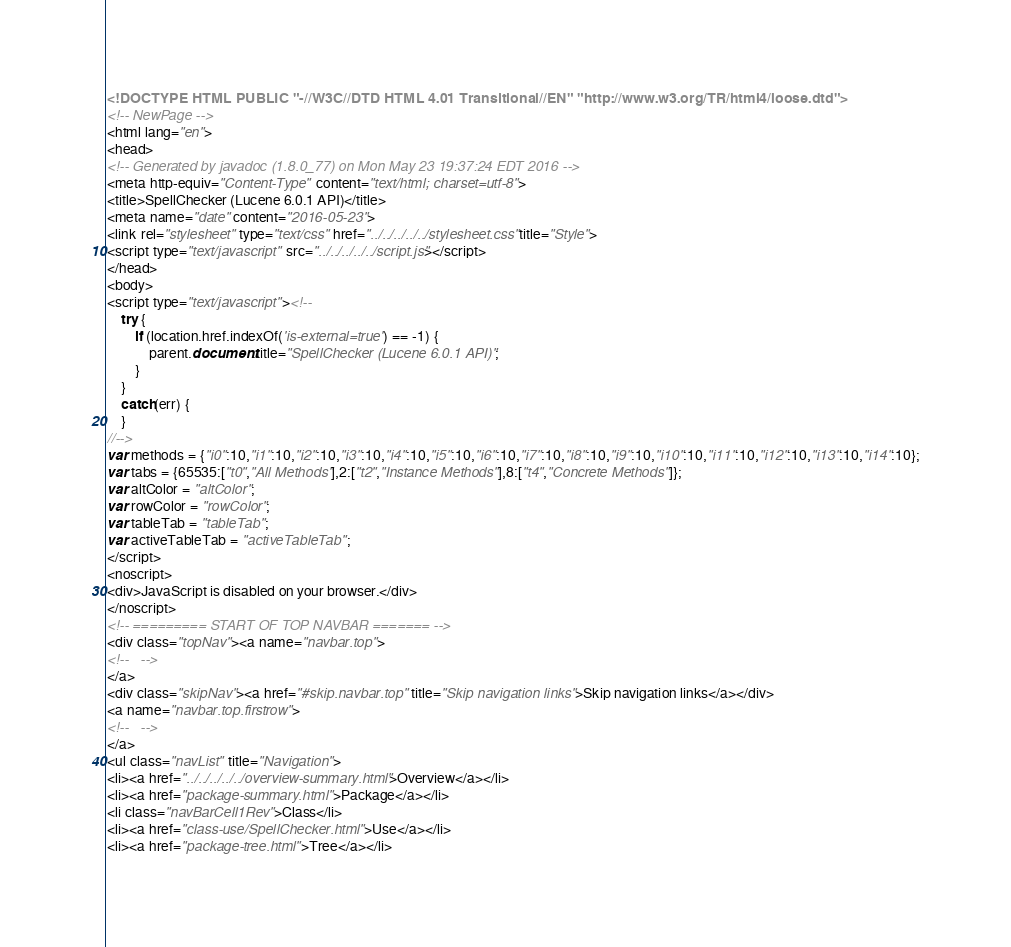<code> <loc_0><loc_0><loc_500><loc_500><_HTML_><!DOCTYPE HTML PUBLIC "-//W3C//DTD HTML 4.01 Transitional//EN" "http://www.w3.org/TR/html4/loose.dtd">
<!-- NewPage -->
<html lang="en">
<head>
<!-- Generated by javadoc (1.8.0_77) on Mon May 23 19:37:24 EDT 2016 -->
<meta http-equiv="Content-Type" content="text/html; charset=utf-8">
<title>SpellChecker (Lucene 6.0.1 API)</title>
<meta name="date" content="2016-05-23">
<link rel="stylesheet" type="text/css" href="../../../../../stylesheet.css" title="Style">
<script type="text/javascript" src="../../../../../script.js"></script>
</head>
<body>
<script type="text/javascript"><!--
    try {
        if (location.href.indexOf('is-external=true') == -1) {
            parent.document.title="SpellChecker (Lucene 6.0.1 API)";
        }
    }
    catch(err) {
    }
//-->
var methods = {"i0":10,"i1":10,"i2":10,"i3":10,"i4":10,"i5":10,"i6":10,"i7":10,"i8":10,"i9":10,"i10":10,"i11":10,"i12":10,"i13":10,"i14":10};
var tabs = {65535:["t0","All Methods"],2:["t2","Instance Methods"],8:["t4","Concrete Methods"]};
var altColor = "altColor";
var rowColor = "rowColor";
var tableTab = "tableTab";
var activeTableTab = "activeTableTab";
</script>
<noscript>
<div>JavaScript is disabled on your browser.</div>
</noscript>
<!-- ========= START OF TOP NAVBAR ======= -->
<div class="topNav"><a name="navbar.top">
<!--   -->
</a>
<div class="skipNav"><a href="#skip.navbar.top" title="Skip navigation links">Skip navigation links</a></div>
<a name="navbar.top.firstrow">
<!--   -->
</a>
<ul class="navList" title="Navigation">
<li><a href="../../../../../overview-summary.html">Overview</a></li>
<li><a href="package-summary.html">Package</a></li>
<li class="navBarCell1Rev">Class</li>
<li><a href="class-use/SpellChecker.html">Use</a></li>
<li><a href="package-tree.html">Tree</a></li></code> 